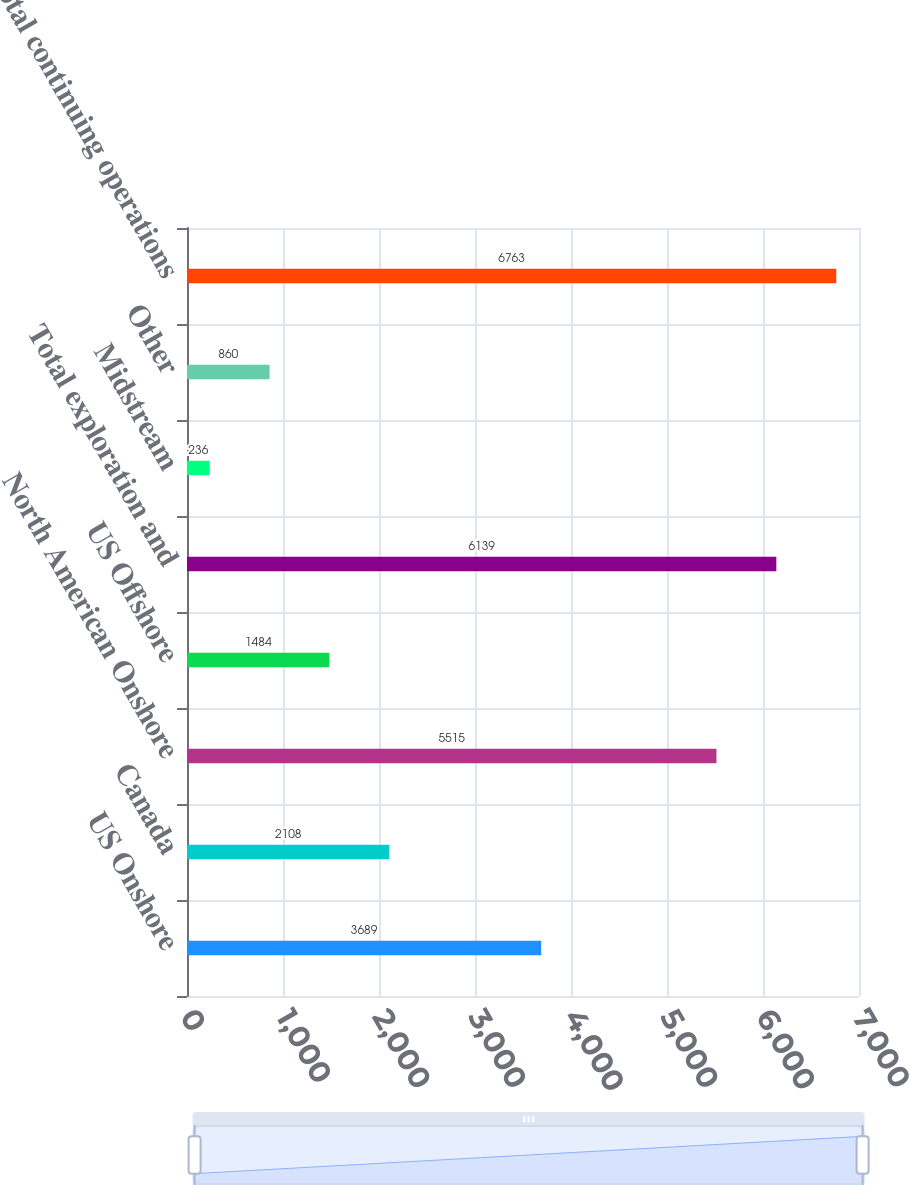Convert chart. <chart><loc_0><loc_0><loc_500><loc_500><bar_chart><fcel>US Onshore<fcel>Canada<fcel>North American Onshore<fcel>US Offshore<fcel>Total exploration and<fcel>Midstream<fcel>Other<fcel>Total continuing operations<nl><fcel>3689<fcel>2108<fcel>5515<fcel>1484<fcel>6139<fcel>236<fcel>860<fcel>6763<nl></chart> 